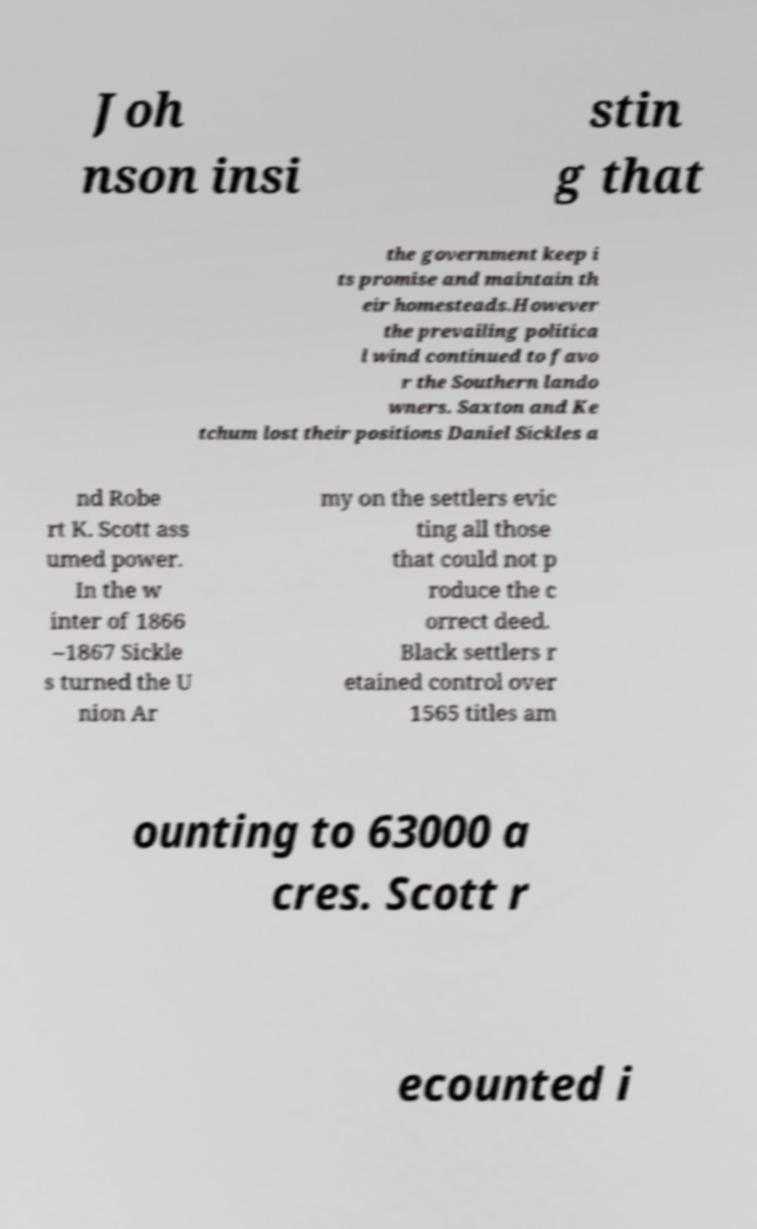Can you read and provide the text displayed in the image?This photo seems to have some interesting text. Can you extract and type it out for me? Joh nson insi stin g that the government keep i ts promise and maintain th eir homesteads.However the prevailing politica l wind continued to favo r the Southern lando wners. Saxton and Ke tchum lost their positions Daniel Sickles a nd Robe rt K. Scott ass umed power. In the w inter of 1866 –1867 Sickle s turned the U nion Ar my on the settlers evic ting all those that could not p roduce the c orrect deed. Black settlers r etained control over 1565 titles am ounting to 63000 a cres. Scott r ecounted i 